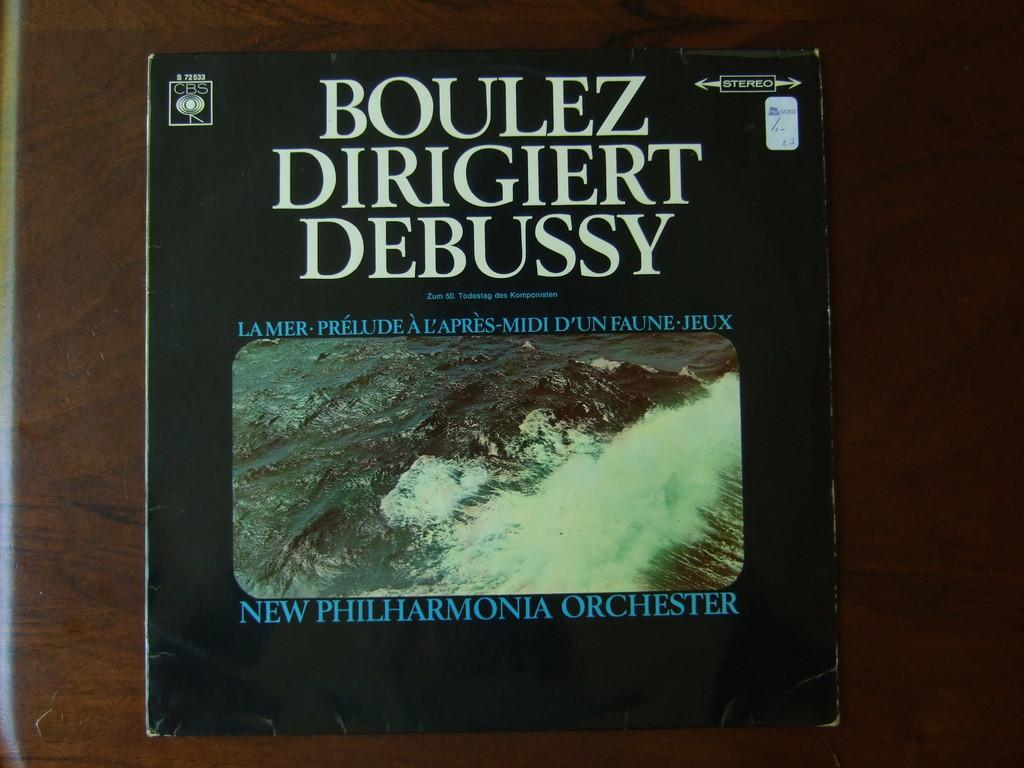<image>
Describe the image concisely. A book about Boulez Dirigiert Debussy is sitting on a table. 